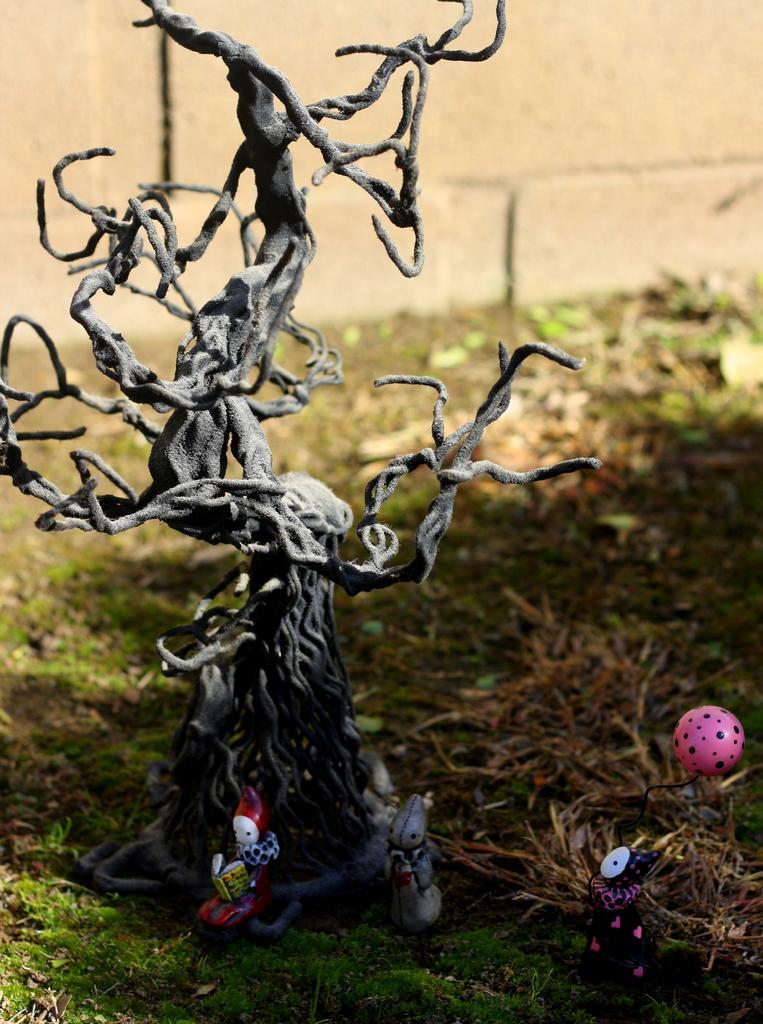In one or two sentences, can you explain what this image depicts? In this image we can see toys that are placed on the grass. In the background there is a wall. 